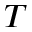<formula> <loc_0><loc_0><loc_500><loc_500>T</formula> 